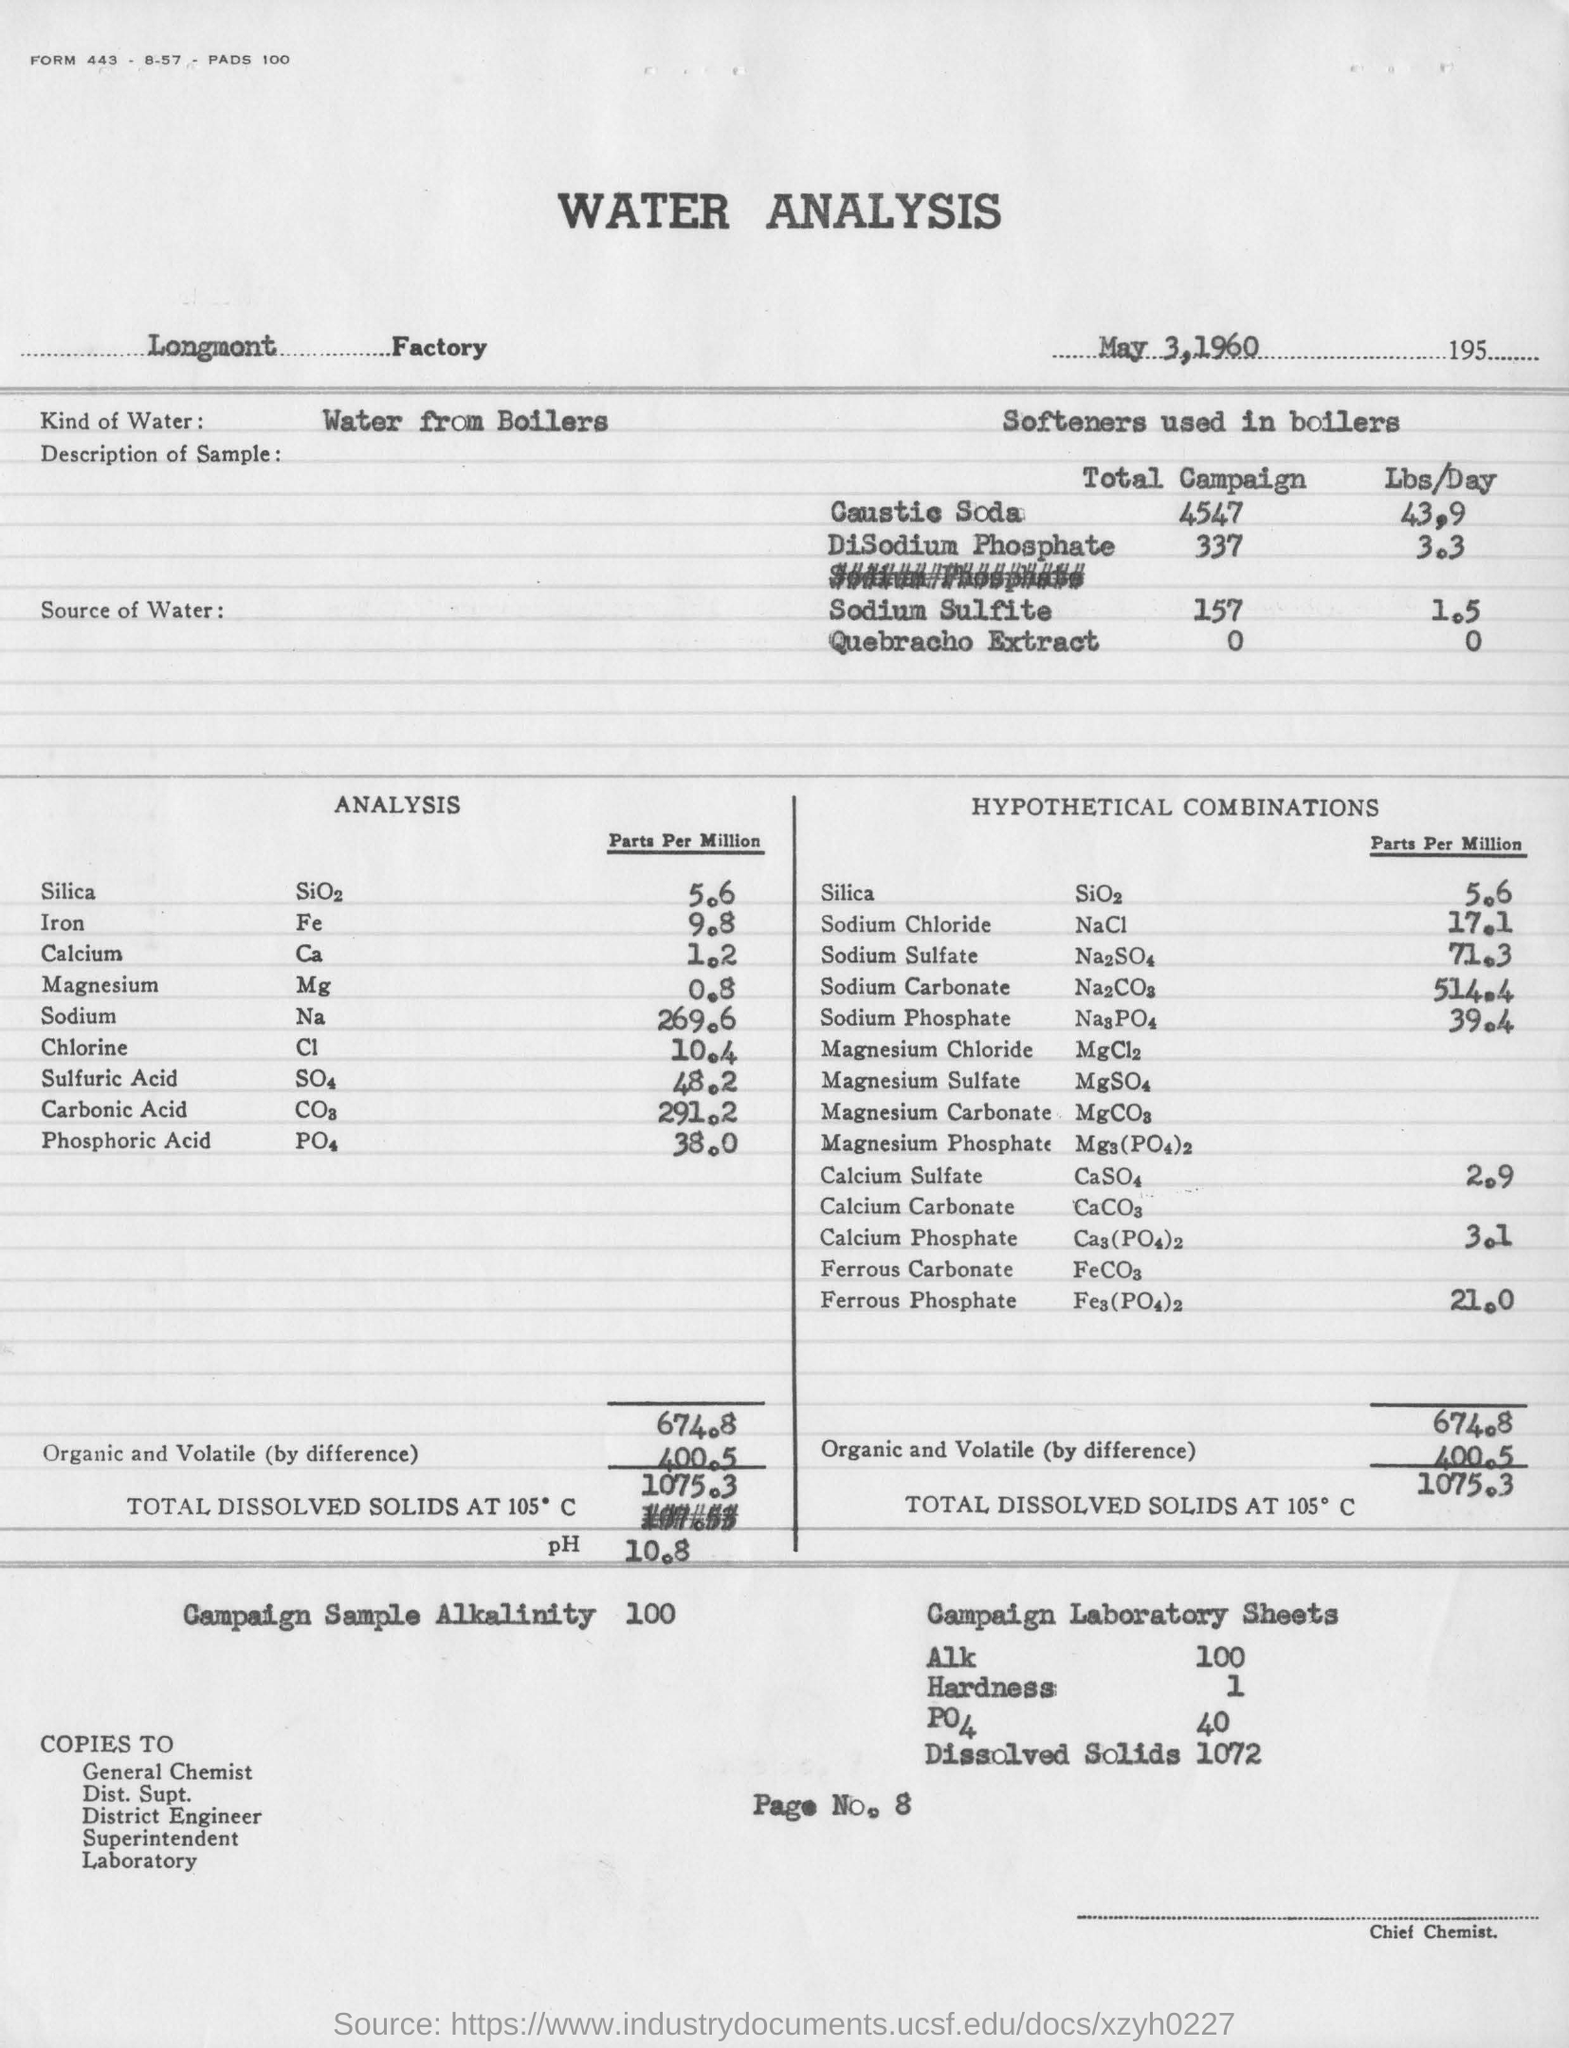Where was the water analysis done?
Your answer should be very brief. Longmont Factory. When is the document "Water Analysis" dated?
Ensure brevity in your answer.  May 3, 1960. What  kind of water was used in the analysis?
Ensure brevity in your answer.  Water from Boilers. What is the page number of this document?
Your response must be concise. Page No.8. What was the pH of the sample?
Your answer should be very brief. 10.8. How many parts per million of Silica was found in the analysis?
Offer a terse response. 5.6 parts per million. What was the Campaign Sample Alkalinity?
Your answer should be compact. 100. 